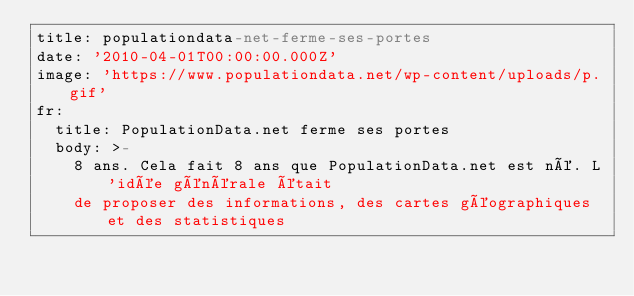Convert code to text. <code><loc_0><loc_0><loc_500><loc_500><_YAML_>title: populationdata-net-ferme-ses-portes
date: '2010-04-01T00:00:00.000Z'
image: 'https://www.populationdata.net/wp-content/uploads/p.gif'
fr:
  title: PopulationData.net ferme ses portes
  body: >-
    8 ans. Cela fait 8 ans que PopulationData.net est né. L'idée générale était
    de proposer des informations, des cartes géographiques et des statistiques</code> 